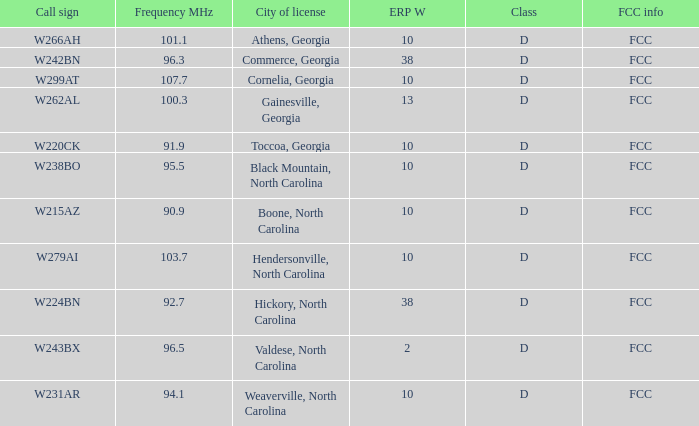What is the mhz frequency for the station identified by the call sign w224bn? 92.7. 